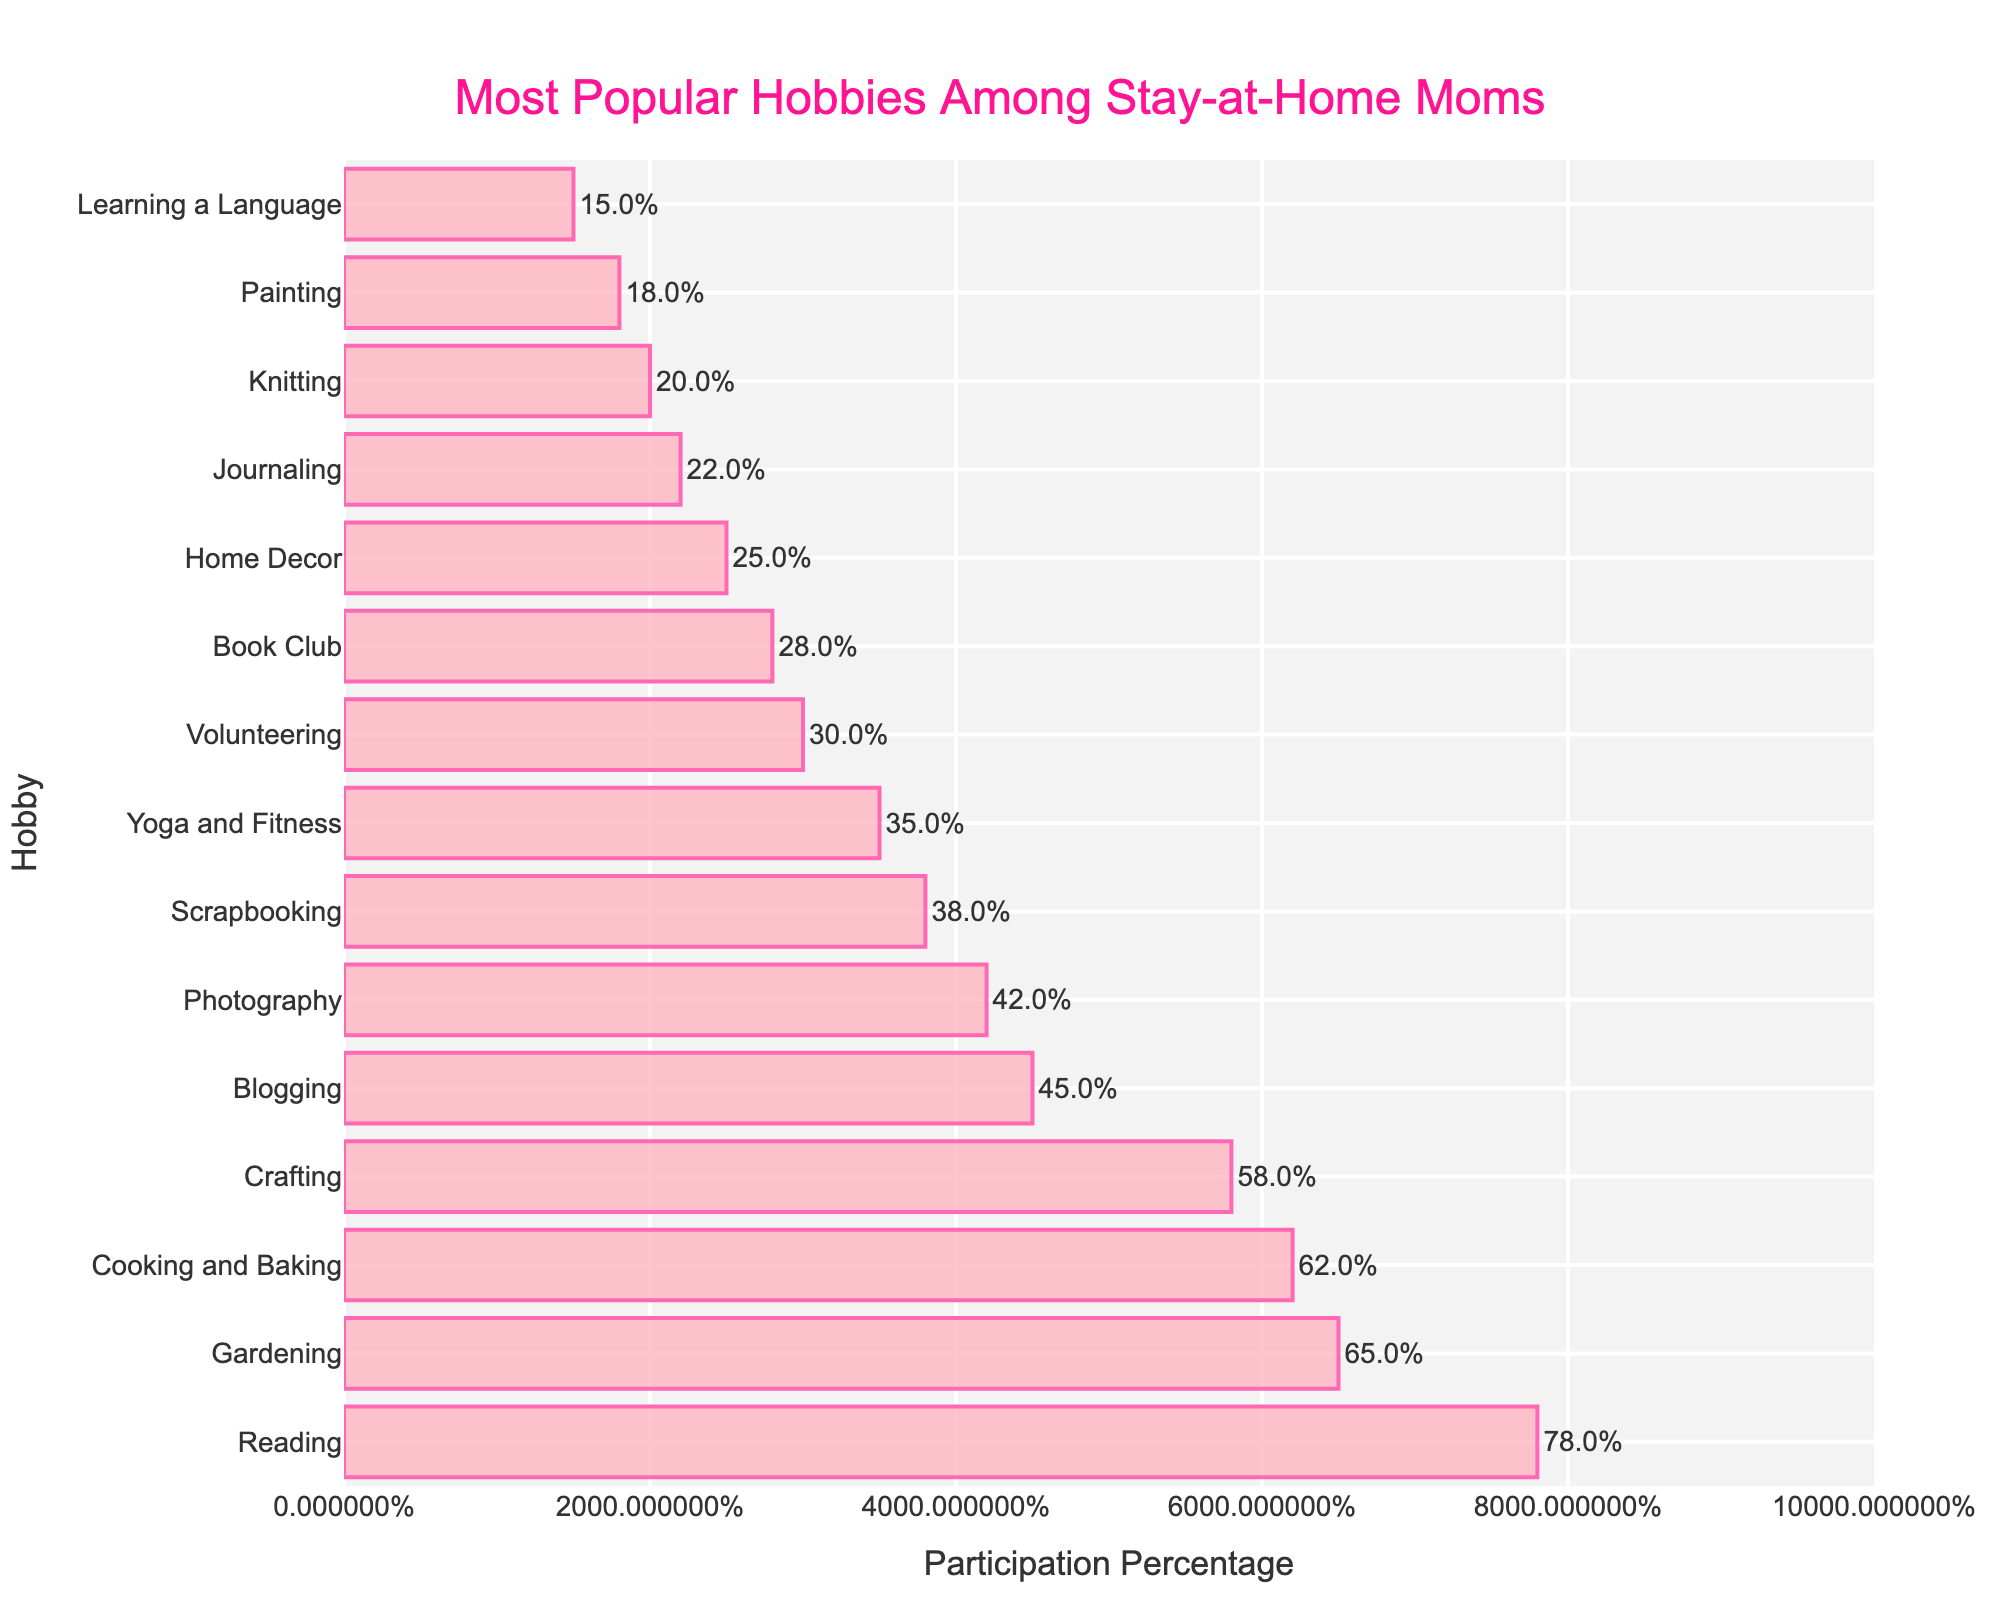Which hobby has the highest participation percentage? Reading has the highest participation percentage according to the chart
Answer: Reading How many percentage points higher is Gardening's participation compared to Yoga and Fitness? Gardening has a participation of 65%, and Yoga and Fitness has 35%. The difference is 65 - 35 = 30%
Answer: 30% What is the total percentage of participation for Crafting, Book Club, and Knitting combined? Crafting has 58%, Book Club has 28%, and Knitting has 20%. Summing these percentages: 58 + 28 + 20 = 106%
Answer: 106% Compare the participation percentage of Blogging and Photography. Which one is higher and by how much? Blogging has 45%, and Photography has 42%. The difference is 45 - 42 = 3%. Blogging is higher by 3%
Answer: Blogging by 3% Among the listed hobbies, which hobby comes last in terms of participation percentage? Learning a Language has the lowest participation percentage in the list with 15%
Answer: Learning a Language Which three hobbies have participation percentages closest to 50%? Crafting has 58%, Blogging has 45%, and Photography has 42%. These percentages are closest to 50%
Answer: Crafting, Blogging, Photography Is the participation percentage for Cooking and Baking more or less than half that of Reading? By how much? Cooking and Baking is 62%, and half of Reading (78%) is 39%. 62% is more by 62 - 39 = 23%
Answer: More by 23% What is the average participation percentage of the top 5 hobbies? The top 5 hobbies and their percentages are Reading (78%), Gardening (65%), Cooking and Baking (62%), Crafting (58%), and Blogging (45%). (78 + 65 + 62 + 58 + 45) / 5 = 61.6%
Answer: 61.6% If the participation percentage of Scrapbooking is doubled, will it exceed that of Cooking and Baking? Scrapbooking has 38%. If doubled, it would be 38 * 2 = 76%. Cooking and Baking has 62%, so yes, 76% exceeds 62%
Answer: Yes 